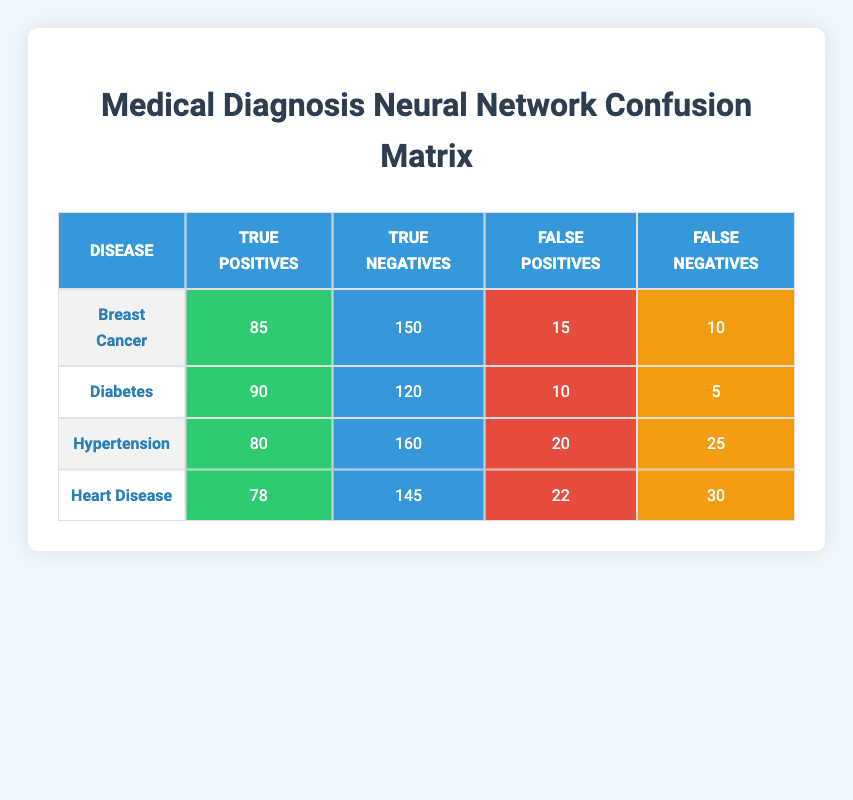What is the True Positive rate for Diabetes? True Positive rate is calculated as True Positives divided by the sum of True Positives and False Negatives. For Diabetes, True Positives are 90 and False Negatives are 5. So, the True Positive rate = 90 / (90 + 5) = 90 / 95 = 0.947 or approximately 94.7%.
Answer: 94.7% Which condition has the highest False Negatives? To find which condition has the highest False Negatives, we compare the values in the False Negatives column. Breast Cancer has 10, Diabetes has 5, Hypertension has 25, and Heart Disease has 30. Heart Disease has the highest value at 30.
Answer: Heart Disease What is the total number of True Positives across all conditions? To find the total number of True Positives, we sum up the True Positives for each condition: 85 (Breast Cancer) + 90 (Diabetes) + 80 (Hypertension) + 78 (Heart Disease) = 333.
Answer: 333 Is the number of False Positives for Hypertension greater than that for Diabetes? False Positives for Hypertension is 20 and for Diabetes is 10. Since 20 is greater than 10, the statement is true.
Answer: Yes What percentage of Heart Disease diagnoses are False Negatives? To calculate the percentage of False Negatives for Heart Disease, we use the formula: (False Negatives / (True Positives + False Negatives)) * 100. For Heart Disease, the False Negatives are 30 and True Positives are 78. Thus, the percentage is (30 / (78 + 30)) * 100 = (30 / 108) * 100 ≈ 27.78%.
Answer: 27.78% 